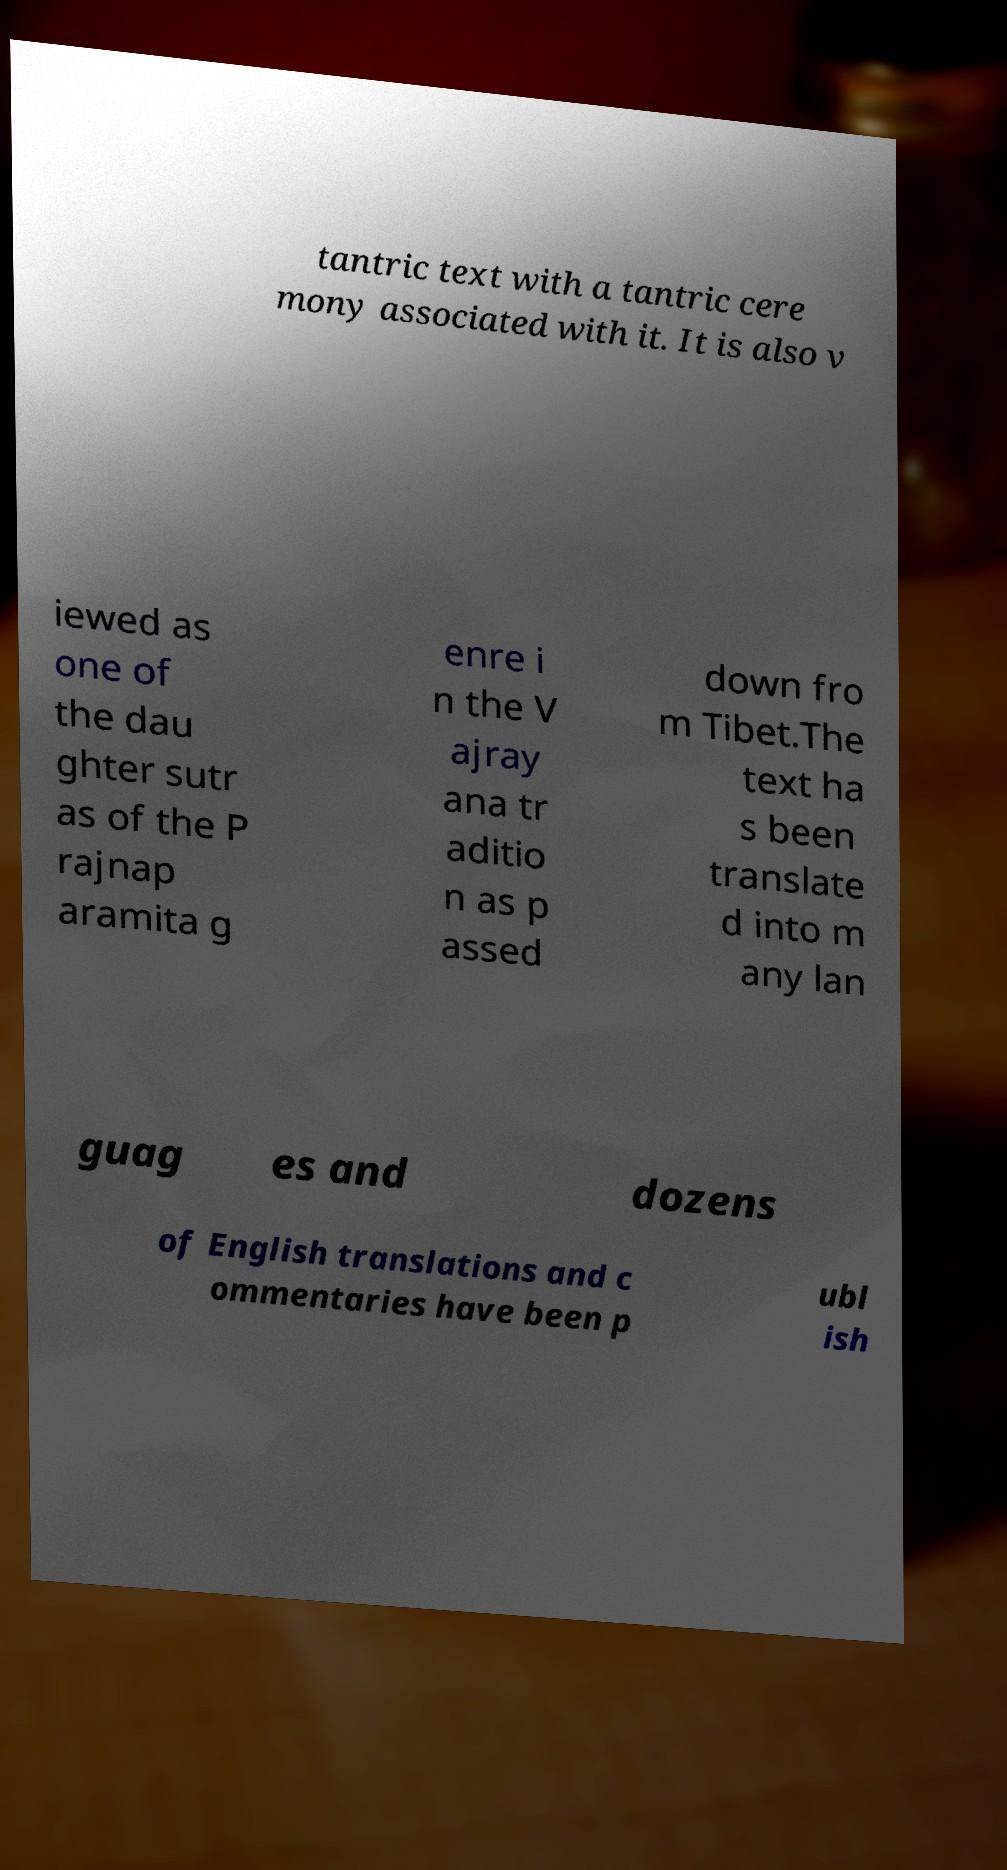What messages or text are displayed in this image? I need them in a readable, typed format. tantric text with a tantric cere mony associated with it. It is also v iewed as one of the dau ghter sutr as of the P rajnap aramita g enre i n the V ajray ana tr aditio n as p assed down fro m Tibet.The text ha s been translate d into m any lan guag es and dozens of English translations and c ommentaries have been p ubl ish 